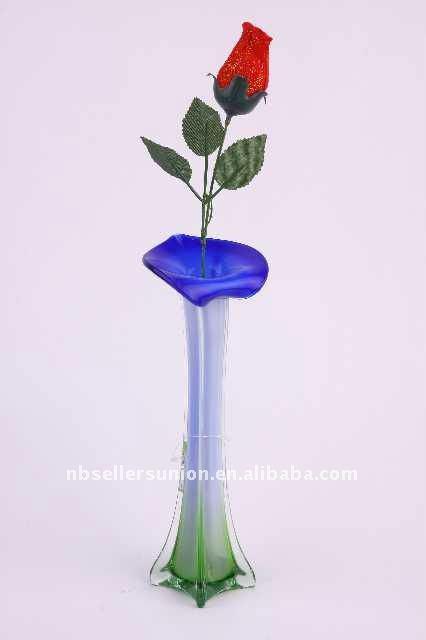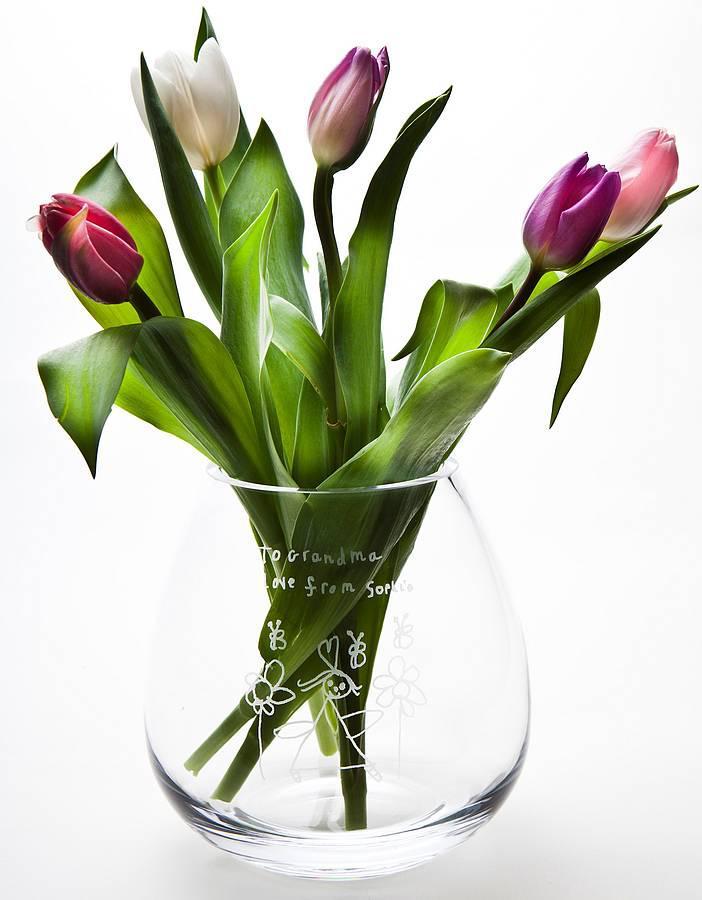The first image is the image on the left, the second image is the image on the right. Given the left and right images, does the statement "At least one of the flowers is a rose." hold true? Answer yes or no. Yes. The first image is the image on the left, the second image is the image on the right. Evaluate the accuracy of this statement regarding the images: "An image shows a vase containing at least one white tulip.". Is it true? Answer yes or no. Yes. 